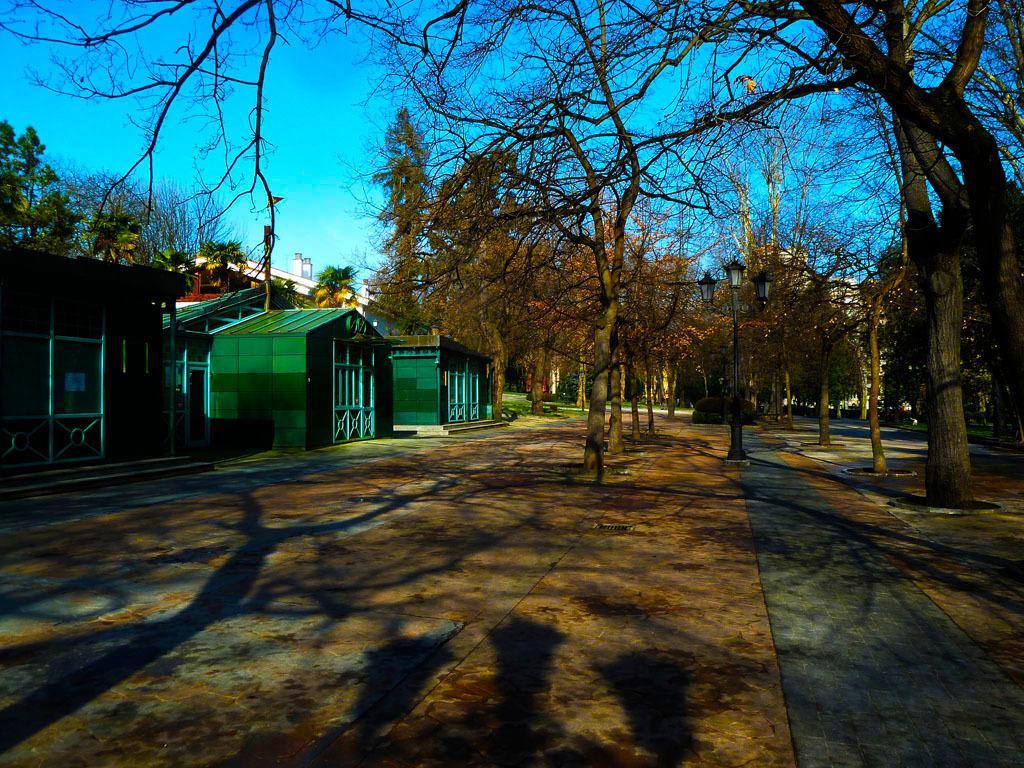Please provide a concise description of this image. Here we can see houses, trees, plants, pole, and lights. In the background there is sky. 